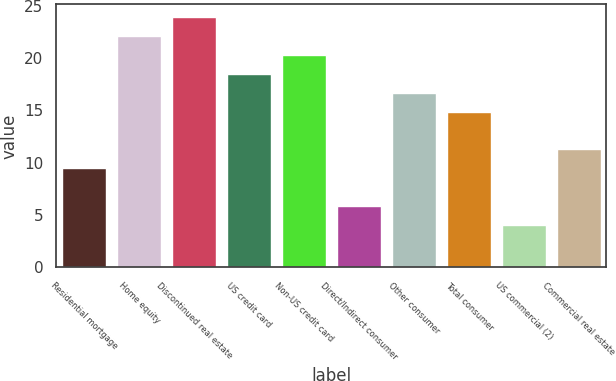Convert chart to OTSL. <chart><loc_0><loc_0><loc_500><loc_500><bar_chart><fcel>Residential mortgage<fcel>Home equity<fcel>Discontinued real estate<fcel>US credit card<fcel>Non-US credit card<fcel>Direct/Indirect consumer<fcel>Other consumer<fcel>Total consumer<fcel>US commercial (2)<fcel>Commercial real estate<nl><fcel>9.47<fcel>22.14<fcel>23.95<fcel>18.52<fcel>20.33<fcel>5.85<fcel>16.71<fcel>14.9<fcel>4.04<fcel>11.28<nl></chart> 